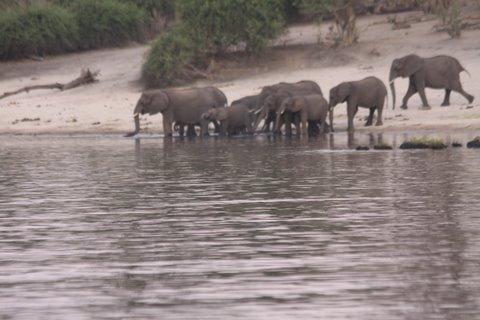Is this the ocean?
Short answer required. No. How many tree branches are in the picture?
Be succinct. 1. Is this most likely natural habitat for a zoo?
Answer briefly. Natural habitat. Are there any elephants in the water?
Give a very brief answer. Yes. What is a group of these animals called?
Concise answer only. Elephants. 